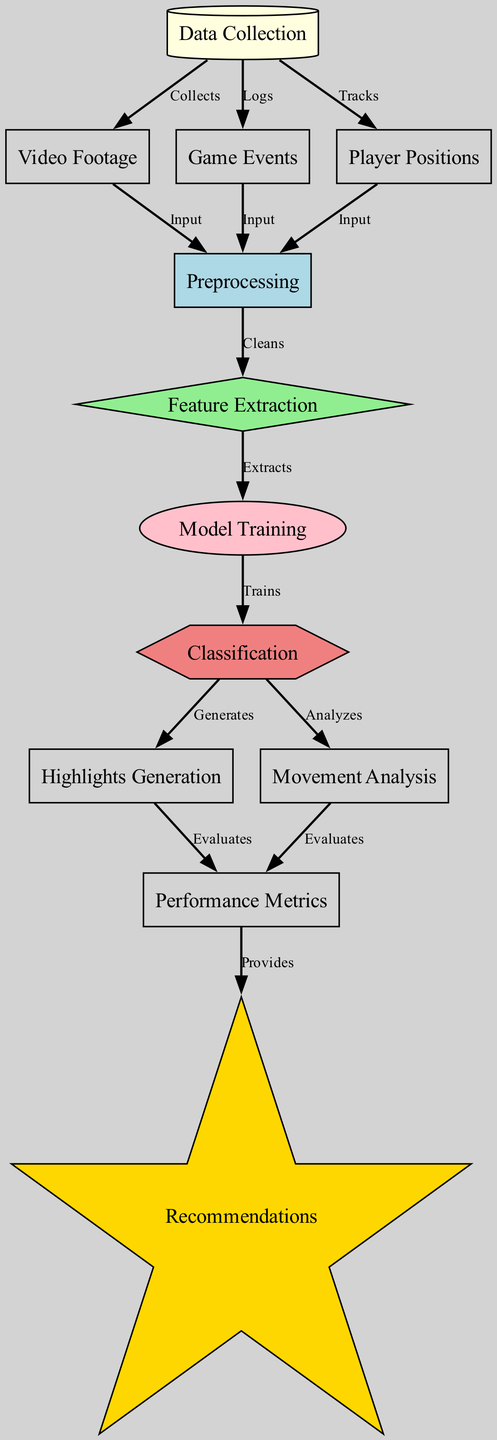What is the first node in the diagram? The first node in the diagram represents the stage of data collection, which involves gathering initial data. Therefore, by examining the nodes laid out, the first one is labeled "Data Collection."
Answer: Data Collection How many edges are there in the diagram? To find the total number of connections (edges) in the diagram, one must count all connections listed in the edges section. There are 13 edges connecting the various nodes in the diagram.
Answer: 13 What type of node is "Model Training"? By referring to the styles defined for each node in the diagram, "Model Training" is specified as an ellipse, indicating its shape in the visual representation.
Answer: Ellipse Which node generates highlights? Following the flow of the diagram, the node responsible for creating highlights is "Highlights Generation," as indicated by its direct connection from the "Classification" node.
Answer: Highlights Generation What does the "Performance Metrics" node provide? Tracing backward from the "Performance Metrics" node, it is evident that this node offers recommendations as its output, thereby characterizing its purpose in the overall process.
Answer: Recommendations What are the three inputs to "Preprocessing"? The "Preprocessing" node receives inputs from three separate nodes: it gets video footage from the node "Video Footage," game event data from "Game Events," and player positions from the "Player Positions" node.
Answer: Video Footage, Game Events, Player Positions Which process follows "Feature Extraction"? Looking at the flow of the diagram, after "Feature Extraction," the next logical stage is "Model Training," as indicated by the directed connection between these two nodes.
Answer: Model Training What connects "Movement Analysis" to "Performance Metrics"? The relationship between these two nodes is depicted as the flow being evaluated; specifically, "Movement Analysis" connects to "Performance Metrics," signifying a cycle of evaluation from player movement to performance insights.
Answer: Evaluates What is the role of the "Classification" node? The "Classification" node takes on a crucial role by analyzing the information processed before it and subsequently generating both highlights and detailed movement analyses based on that classification.
Answer: Analyzes 